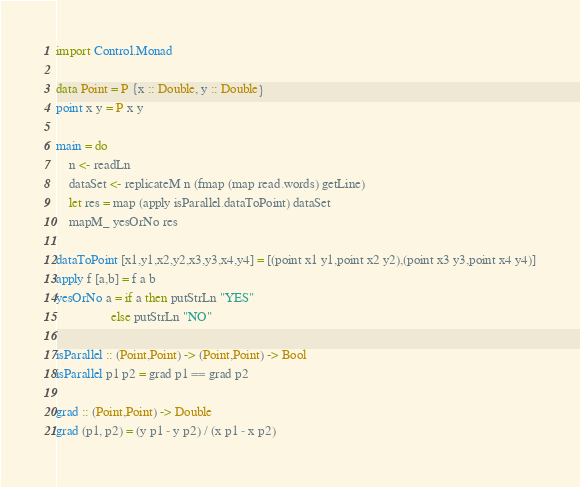Convert code to text. <code><loc_0><loc_0><loc_500><loc_500><_Haskell_>import Control.Monad

data Point = P {x :: Double, y :: Double}
point x y = P x y

main = do
    n <- readLn
    dataSet <- replicateM n (fmap (map read.words) getLine)
    let res = map (apply isParallel.dataToPoint) dataSet
    mapM_ yesOrNo res

dataToPoint [x1,y1,x2,y2,x3,y3,x4,y4] = [(point x1 y1,point x2 y2),(point x3 y3,point x4 y4)]
apply f [a,b] = f a b
yesOrNo a = if a then putStrLn "YES"
                 else putStrLn "NO"

isParallel :: (Point,Point) -> (Point,Point) -> Bool
isParallel p1 p2 = grad p1 == grad p2

grad :: (Point,Point) -> Double
grad (p1, p2) = (y p1 - y p2) / (x p1 - x p2)</code> 